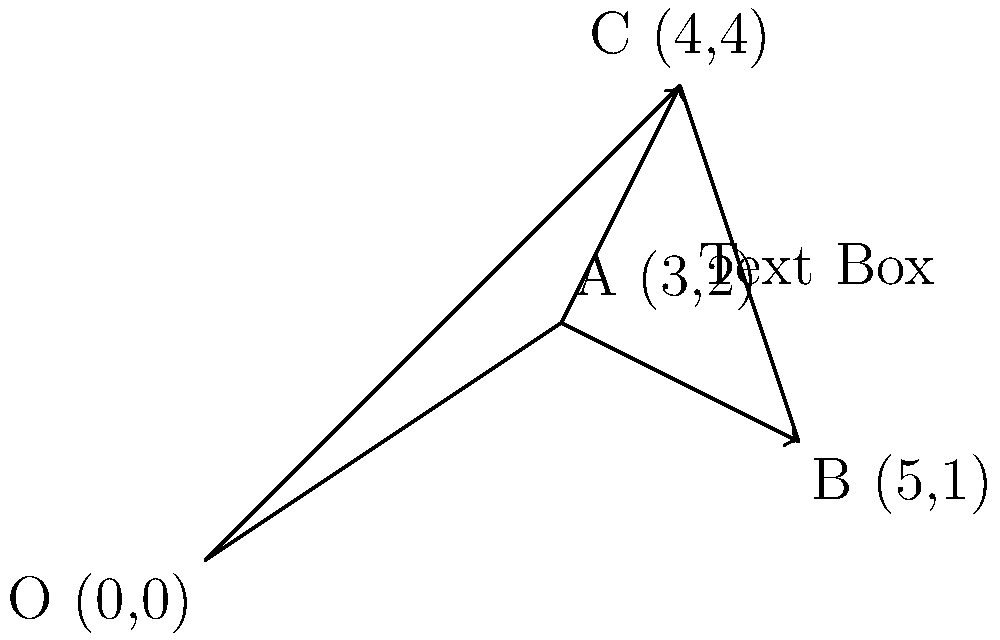In a UI design for a multilingual app, you need to determine the optimal placement for a translated text box within a constrained space. The space is represented by the quadrilateral OABC in the coordinate system, where O(0,0) is the origin. The current position of the text box is at point A(3,2). You want to move it towards either point B(5,1) or point C(4,4), whichever provides more space for the text to expand. Calculate the vector that represents the optimal movement direction and magnitude for the text box placement. To solve this problem, we need to follow these steps:

1. Calculate the vectors from A to B and A to C:
   Vector AB = B - A = (5-3, 1-2) = (2, -1)
   Vector AC = C - A = (4-3, 4-2) = (1, 2)

2. Calculate the magnitudes of these vectors:
   |AB| = $\sqrt{2^2 + (-1)^2} = \sqrt{5}$
   |AC| = $\sqrt{1^2 + 2^2} = \sqrt{5}$

3. Since both vectors have the same magnitude, we need to consider which direction provides more space for text expansion. In this case, moving towards C (upwards) generally provides more vertical space for text, which is often preferable in UI design.

4. Therefore, the optimal movement vector is AC = (1, 2)

5. To express this as a single vector, we can use the vector notation:
   $\vec{v} = 1\hat{i} + 2\hat{j}$

   Where $\hat{i}$ is the unit vector in the x-direction and $\hat{j}$ is the unit vector in the y-direction.
Answer: $\vec{v} = 1\hat{i} + 2\hat{j}$ 